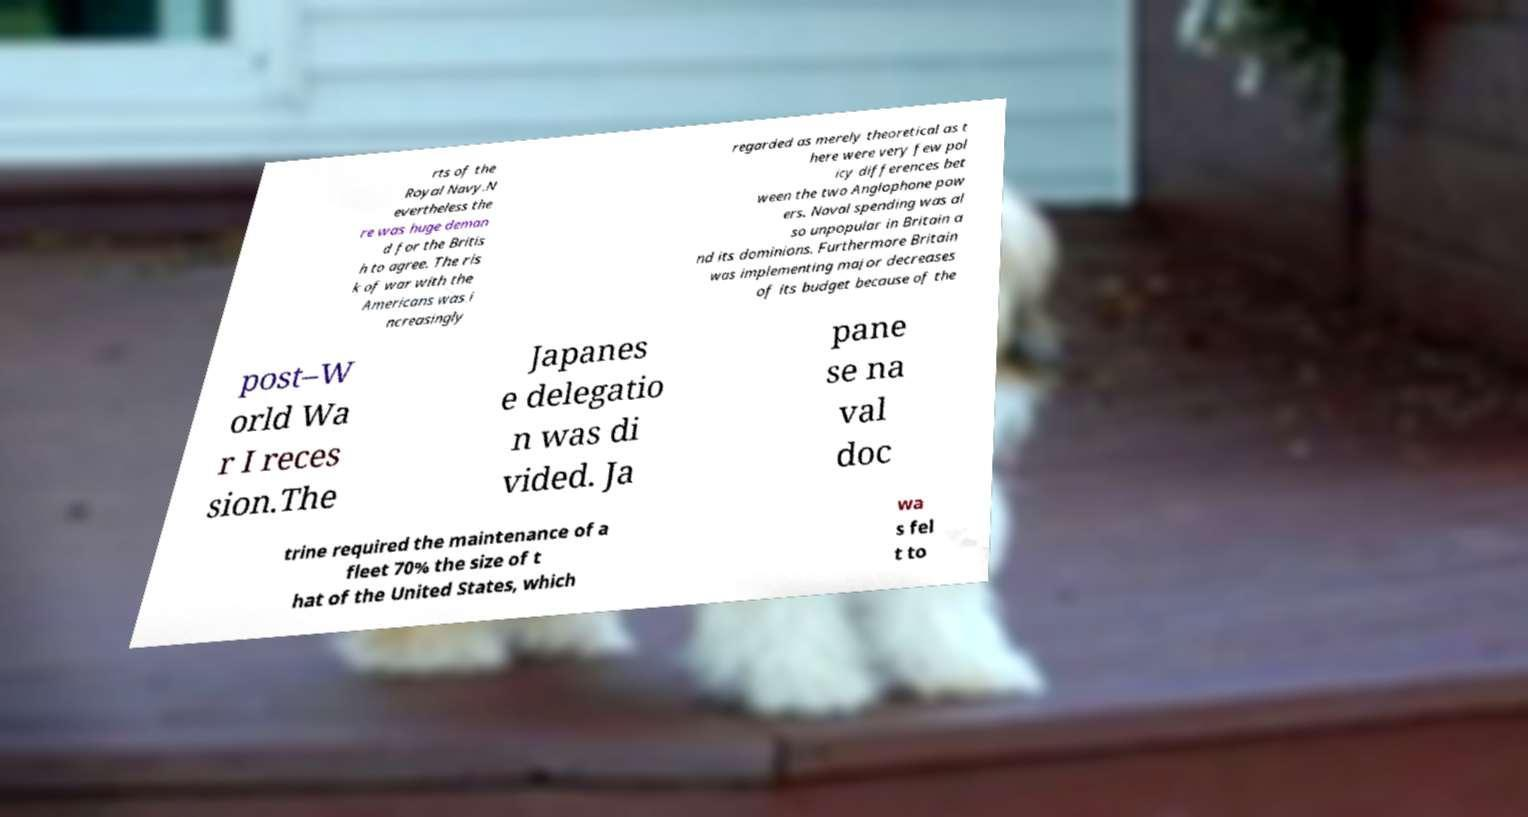Can you accurately transcribe the text from the provided image for me? rts of the Royal Navy.N evertheless the re was huge deman d for the Britis h to agree. The ris k of war with the Americans was i ncreasingly regarded as merely theoretical as t here were very few pol icy differences bet ween the two Anglophone pow ers. Naval spending was al so unpopular in Britain a nd its dominions. Furthermore Britain was implementing major decreases of its budget because of the post–W orld Wa r I reces sion.The Japanes e delegatio n was di vided. Ja pane se na val doc trine required the maintenance of a fleet 70% the size of t hat of the United States, which wa s fel t to 